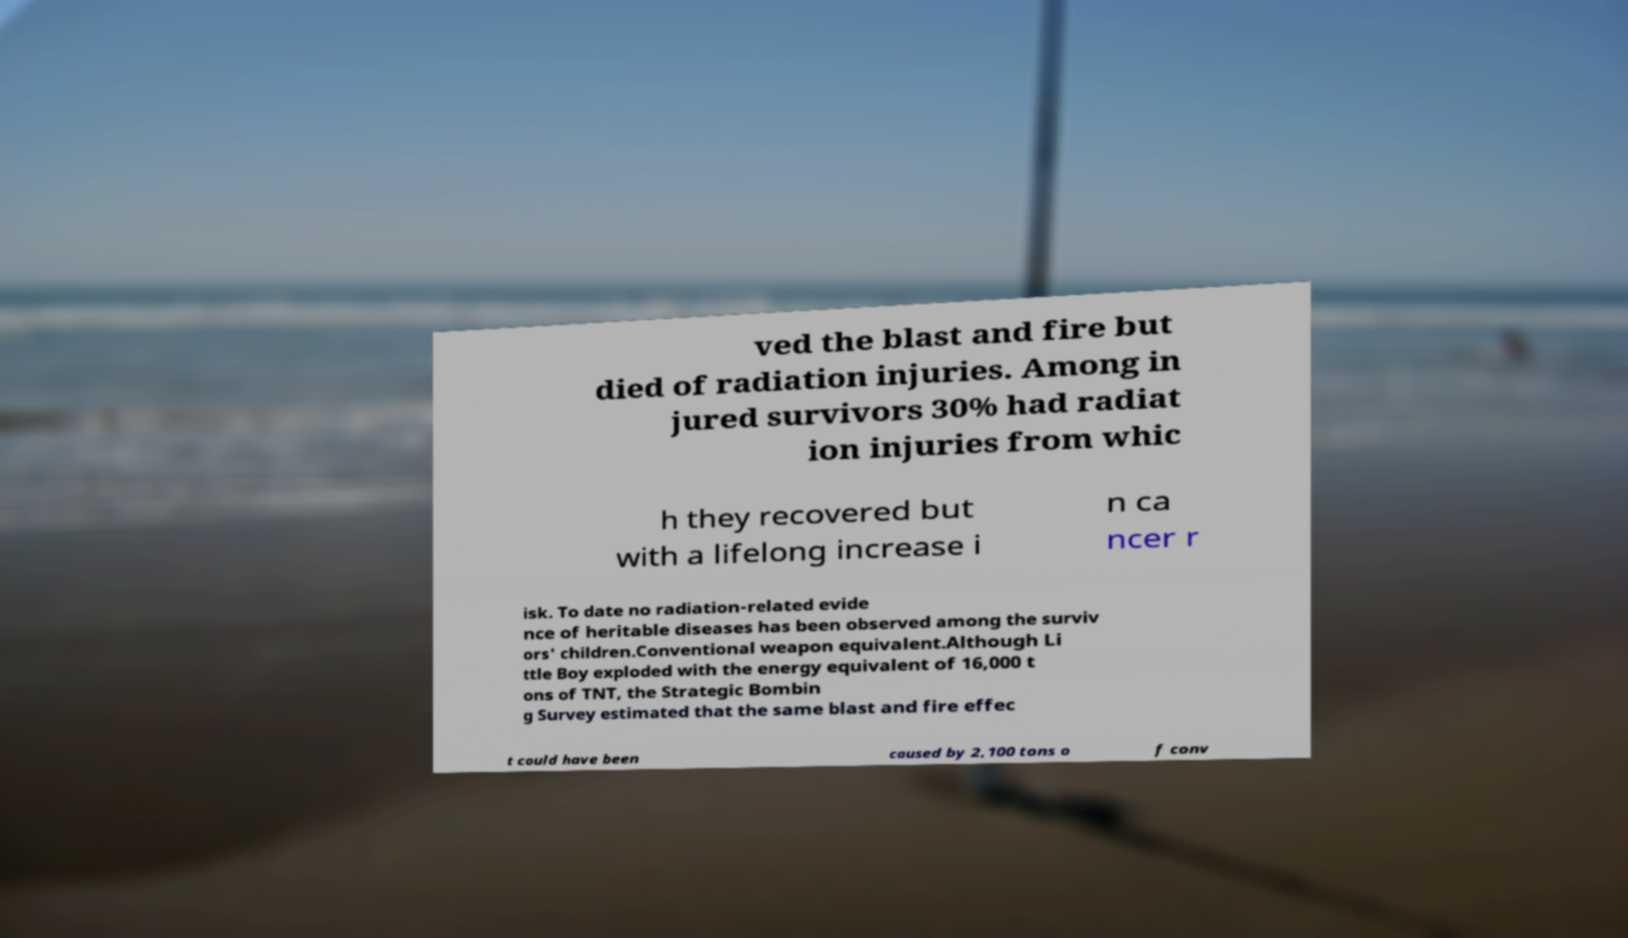There's text embedded in this image that I need extracted. Can you transcribe it verbatim? ved the blast and fire but died of radiation injuries. Among in jured survivors 30% had radiat ion injuries from whic h they recovered but with a lifelong increase i n ca ncer r isk. To date no radiation-related evide nce of heritable diseases has been observed among the surviv ors' children.Conventional weapon equivalent.Although Li ttle Boy exploded with the energy equivalent of 16,000 t ons of TNT, the Strategic Bombin g Survey estimated that the same blast and fire effec t could have been caused by 2,100 tons o f conv 